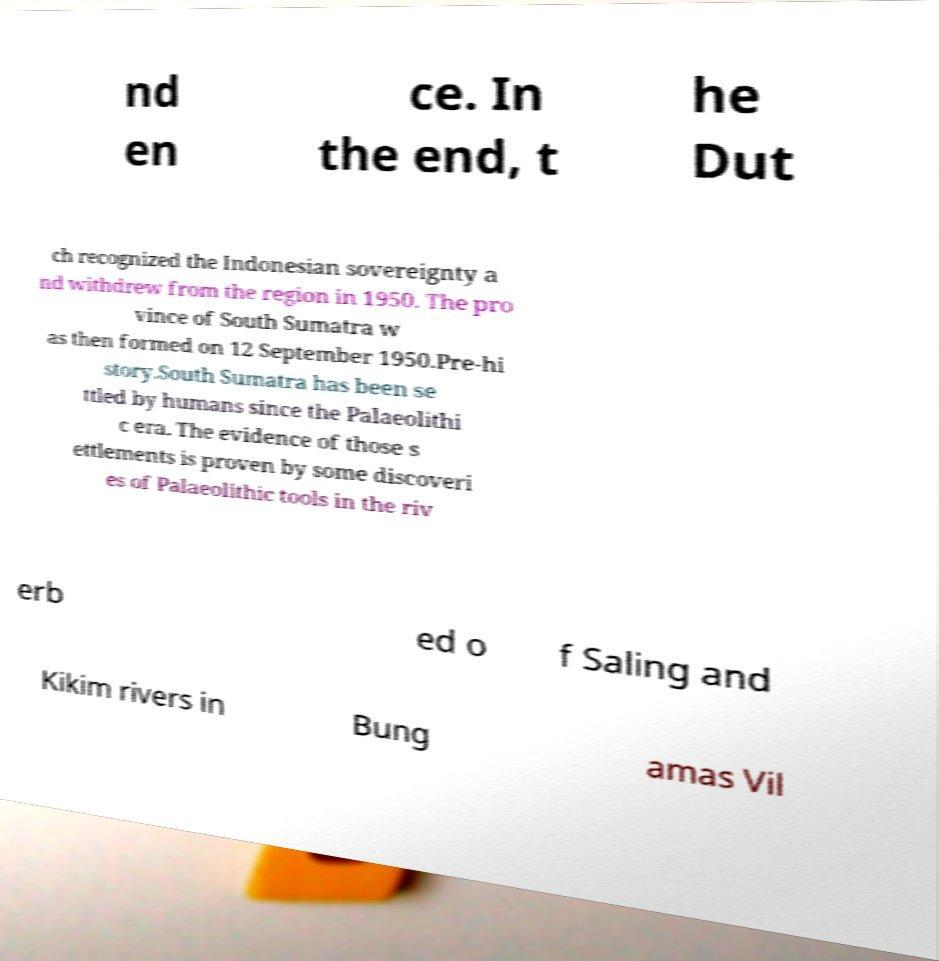There's text embedded in this image that I need extracted. Can you transcribe it verbatim? nd en ce. In the end, t he Dut ch recognized the Indonesian sovereignty a nd withdrew from the region in 1950. The pro vince of South Sumatra w as then formed on 12 September 1950.Pre-hi story.South Sumatra has been se ttled by humans since the Palaeolithi c era. The evidence of those s ettlements is proven by some discoveri es of Palaeolithic tools in the riv erb ed o f Saling and Kikim rivers in Bung amas Vil 